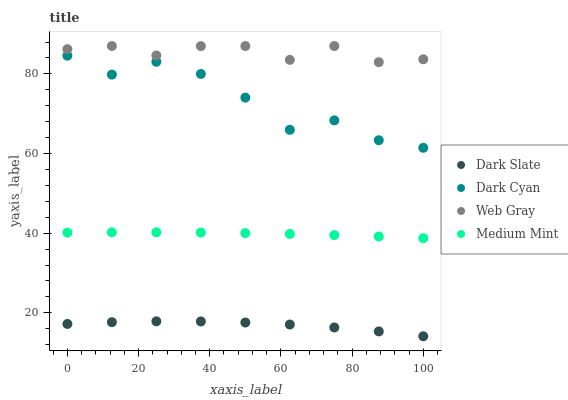Does Dark Slate have the minimum area under the curve?
Answer yes or no. Yes. Does Web Gray have the maximum area under the curve?
Answer yes or no. Yes. Does Web Gray have the minimum area under the curve?
Answer yes or no. No. Does Dark Slate have the maximum area under the curve?
Answer yes or no. No. Is Medium Mint the smoothest?
Answer yes or no. Yes. Is Dark Cyan the roughest?
Answer yes or no. Yes. Is Dark Slate the smoothest?
Answer yes or no. No. Is Dark Slate the roughest?
Answer yes or no. No. Does Dark Slate have the lowest value?
Answer yes or no. Yes. Does Web Gray have the lowest value?
Answer yes or no. No. Does Web Gray have the highest value?
Answer yes or no. Yes. Does Dark Slate have the highest value?
Answer yes or no. No. Is Dark Slate less than Web Gray?
Answer yes or no. Yes. Is Dark Cyan greater than Dark Slate?
Answer yes or no. Yes. Does Dark Slate intersect Web Gray?
Answer yes or no. No. 